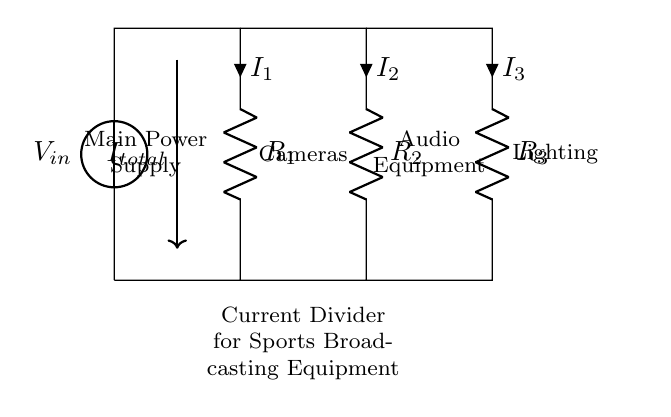What is the total current entering the circuit? The total current entering the circuit is represented by the label \( I_{total} \) in the diagram. According to Ohm's law, the total current is the sum of the currents through each resistor.
Answer: I total What are the components in this circuit? The circuit consists of a voltage source and three resistors labeled \( R_1 \), \( R_2 \), and \( R_3 \). The voltage source supplies the input voltage to the circuit, while the resistors divide the current.
Answer: Voltage source, R1, R2, R3 Which equipment is connected to the resistor R2? The resistor \( R_2 \) is connected to the cameras, as indicated in the circuit diagram by the label next to the resistor.
Answer: Cameras How does the current divide among the branches? The current divides inversely with the resistance values in each branch. A lower resistance will have a higher current share, while a higher resistance will have a lower current share. This relationship is due to Ohm's law and the characteristics of a current divider.
Answer: Inversely with resistance What role does the voltage source play in this circuit? The voltage source provides the necessary electrical energy for the circuit. It establishes the potential difference that drives the current through the resistors, ensuring that the broadcasting equipment receives the required power.
Answer: Provides electrical energy What is the significance of the current divider in this setup? The current divider allows for the distribution of electrical power to multiple devices such as cameras, audio equipment, and lighting. Each device can operate effectively with a portion of the total current, tailored to their specific requirements.
Answer: Distributes power to devices 